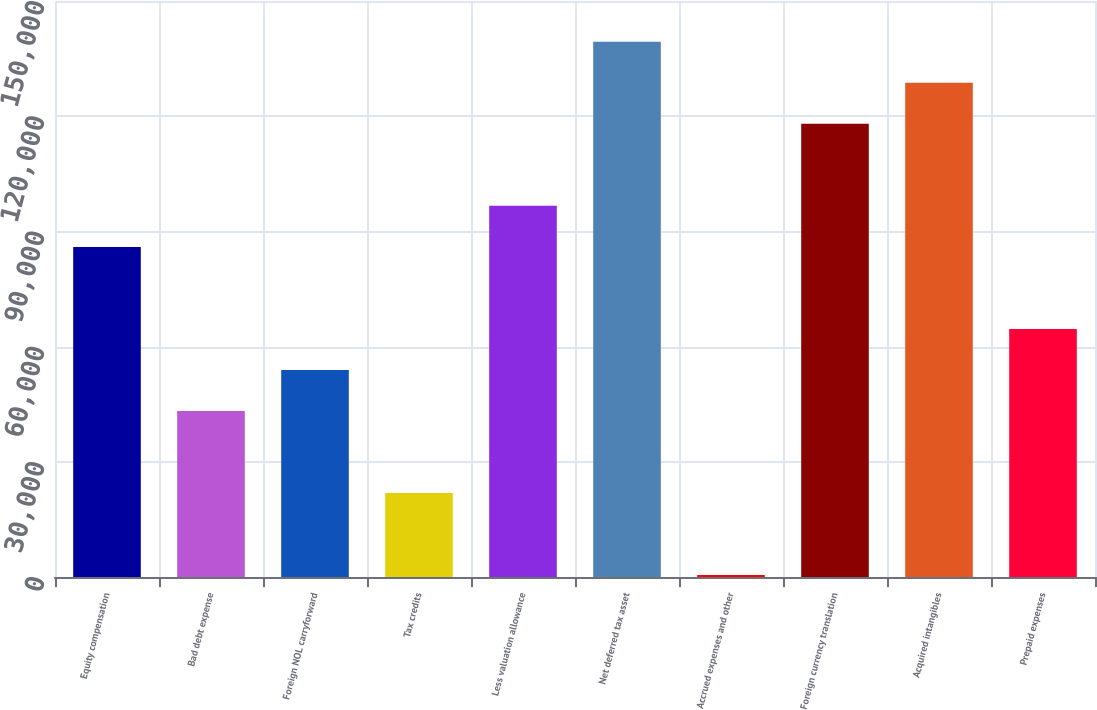Convert chart to OTSL. <chart><loc_0><loc_0><loc_500><loc_500><bar_chart><fcel>Equity compensation<fcel>Bad debt expense<fcel>Foreign NOL carryforward<fcel>Tax credits<fcel>Less valuation allowance<fcel>Net deferred tax asset<fcel>Accrued expenses and other<fcel>Foreign currency translation<fcel>Acquired intangibles<fcel>Prepaid expenses<nl><fcel>85969.4<fcel>43232.2<fcel>53916.5<fcel>21863.6<fcel>96653.7<fcel>139391<fcel>495<fcel>118022<fcel>128707<fcel>64600.8<nl></chart> 